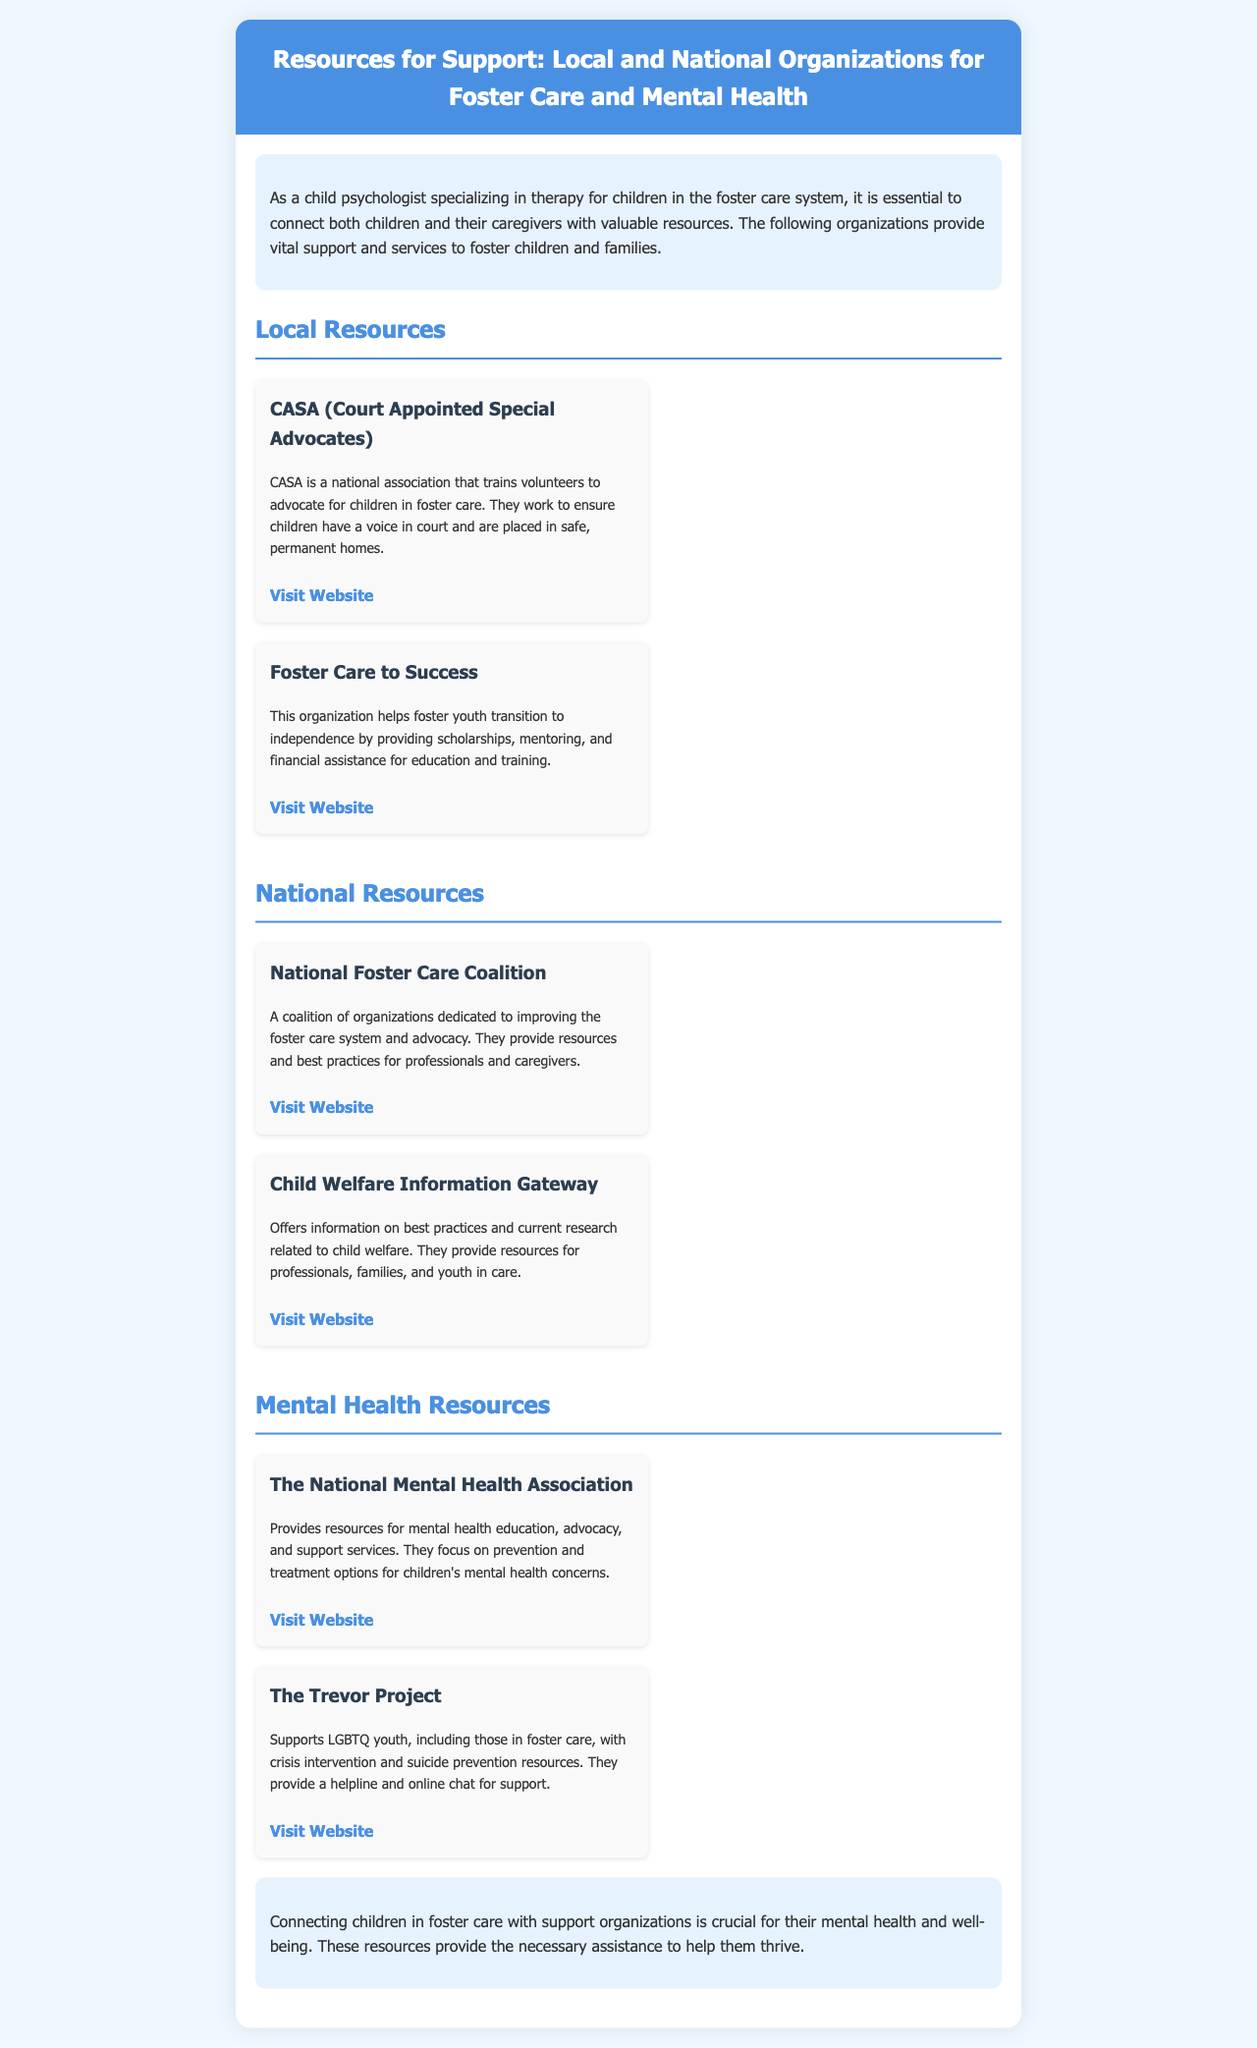what is the title of the brochure? The title of the brochure is prominently displayed in the header section.
Answer: Resources for Support: Local and National Organizations for Foster Care and Mental Health what is CASA? CASA is a national association that trains volunteers to advocate for children in foster care.
Answer: Court Appointed Special Advocates how many local resources are listed in the brochure? The brochure lists a total of two local resources.
Answer: 2 what organization helps foster youth transition to independence? This organization provides scholarships and mentoring specifically for foster youth.
Answer: Foster Care to Success which organization is dedicated to improving the foster care system? The National Foster Care Coalition aims to enhance the foster care system.
Answer: National Foster Care Coalition what support does The Trevor Project offer? They provide a helpline and online chat, specifically focused on suicide prevention resources.
Answer: Crisis intervention and suicide prevention what type of children does The National Mental Health Association focus on? The organization focuses on prevention and treatment options for mental health concerns in children.
Answer: Children's mental health what is found in the closing section of the brochure? The closing section emphasizes the importance of connecting children with support organizations.
Answer: Importance of connection for mental health and well-being 